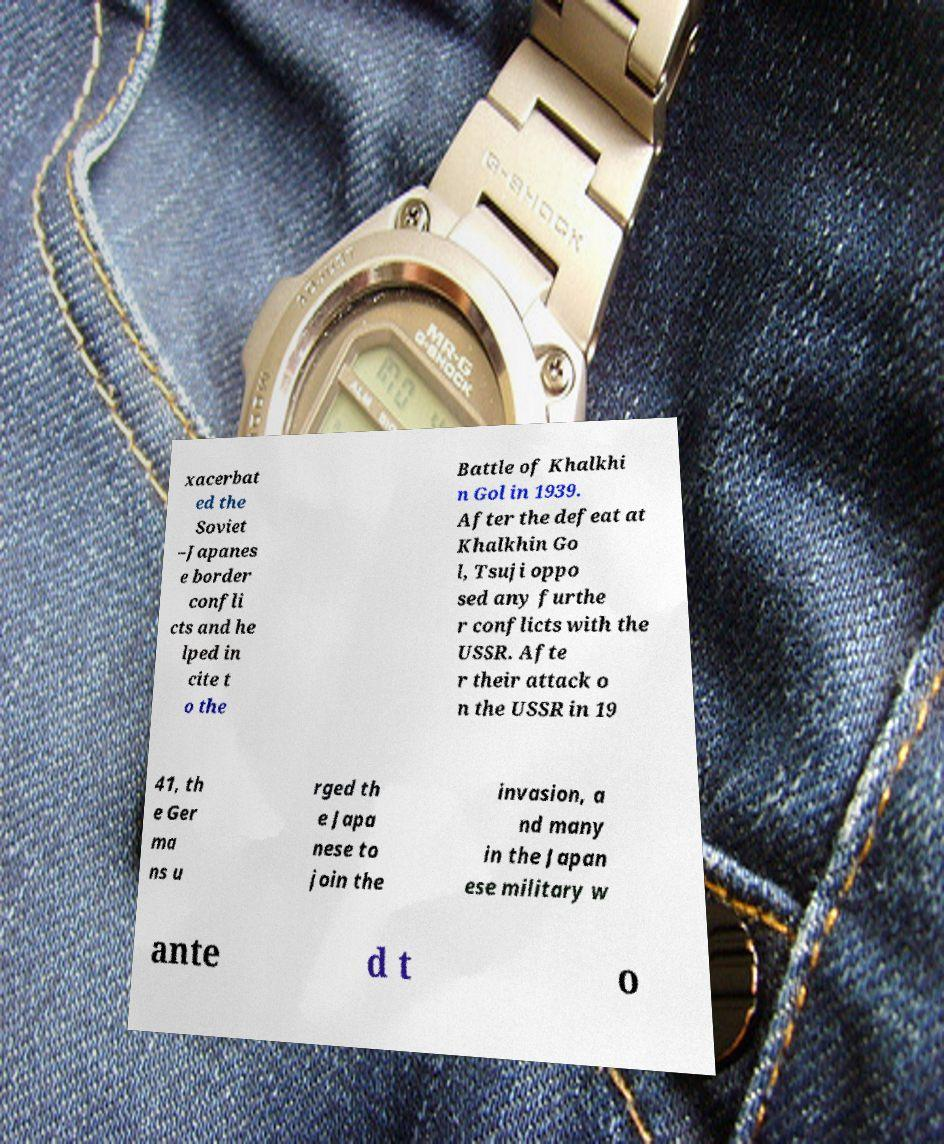For documentation purposes, I need the text within this image transcribed. Could you provide that? xacerbat ed the Soviet –Japanes e border confli cts and he lped in cite t o the Battle of Khalkhi n Gol in 1939. After the defeat at Khalkhin Go l, Tsuji oppo sed any furthe r conflicts with the USSR. Afte r their attack o n the USSR in 19 41, th e Ger ma ns u rged th e Japa nese to join the invasion, a nd many in the Japan ese military w ante d t o 